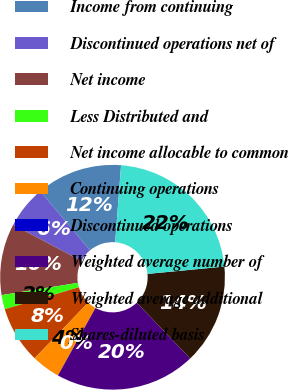<chart> <loc_0><loc_0><loc_500><loc_500><pie_chart><fcel>Income from continuing<fcel>Discontinued operations net of<fcel>Net income<fcel>Less Distributed and<fcel>Net income allocable to common<fcel>Continuing operations<fcel>Discontinued operations<fcel>Weighted average number of<fcel>Weighted average additional<fcel>Shares-diluted basis<nl><fcel>12.32%<fcel>6.16%<fcel>10.27%<fcel>2.05%<fcel>8.22%<fcel>4.11%<fcel>0.0%<fcel>20.22%<fcel>14.38%<fcel>22.27%<nl></chart> 